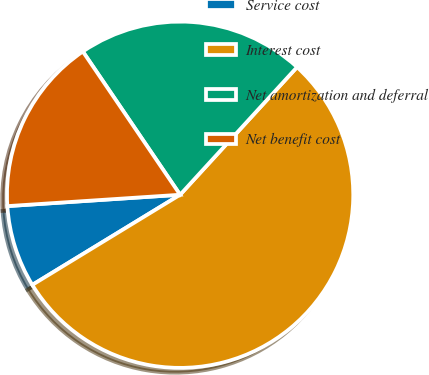Convert chart. <chart><loc_0><loc_0><loc_500><loc_500><pie_chart><fcel>Service cost<fcel>Interest cost<fcel>Net amortization and deferral<fcel>Net benefit cost<nl><fcel>7.67%<fcel>54.48%<fcel>21.3%<fcel>16.55%<nl></chart> 